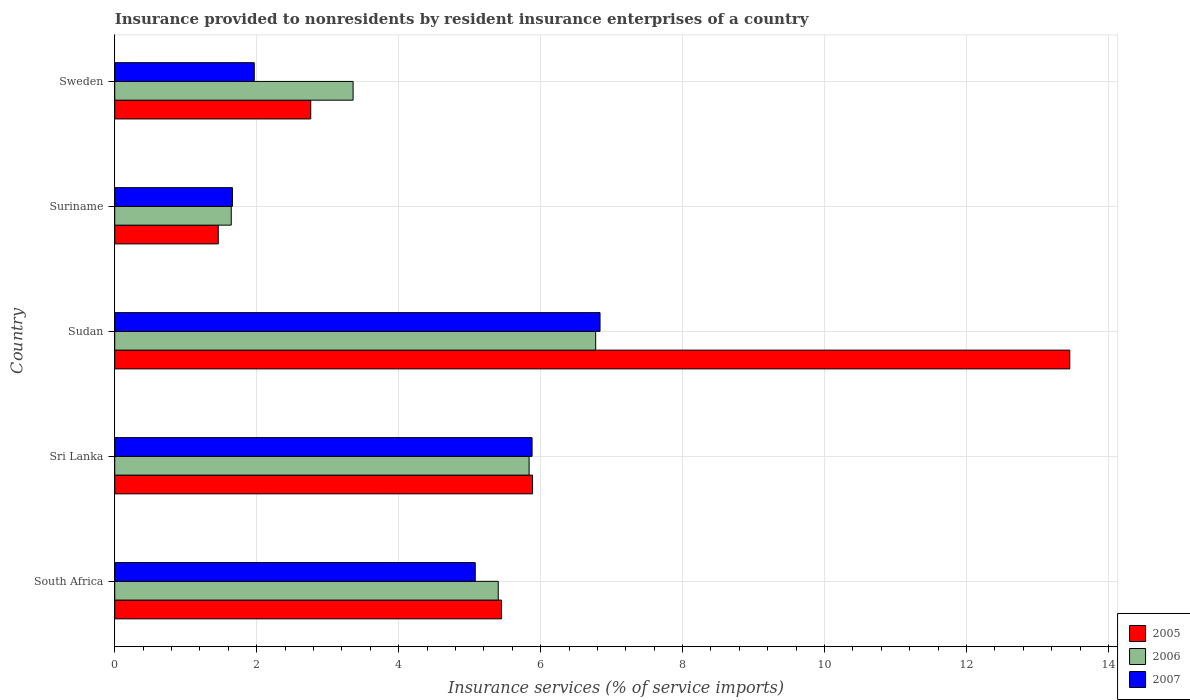How many different coloured bars are there?
Provide a short and direct response. 3. Are the number of bars on each tick of the Y-axis equal?
Offer a terse response. Yes. How many bars are there on the 3rd tick from the top?
Make the answer very short. 3. What is the label of the 5th group of bars from the top?
Provide a succinct answer. South Africa. In how many cases, is the number of bars for a given country not equal to the number of legend labels?
Provide a succinct answer. 0. What is the insurance provided to nonresidents in 2007 in Suriname?
Offer a terse response. 1.66. Across all countries, what is the maximum insurance provided to nonresidents in 2006?
Ensure brevity in your answer.  6.78. Across all countries, what is the minimum insurance provided to nonresidents in 2005?
Offer a very short reply. 1.46. In which country was the insurance provided to nonresidents in 2006 maximum?
Your response must be concise. Sudan. In which country was the insurance provided to nonresidents in 2007 minimum?
Give a very brief answer. Suriname. What is the total insurance provided to nonresidents in 2005 in the graph?
Provide a succinct answer. 29.01. What is the difference between the insurance provided to nonresidents in 2005 in South Africa and that in Suriname?
Provide a short and direct response. 3.99. What is the difference between the insurance provided to nonresidents in 2007 in Sudan and the insurance provided to nonresidents in 2006 in Sweden?
Keep it short and to the point. 3.48. What is the average insurance provided to nonresidents in 2005 per country?
Your answer should be compact. 5.8. What is the difference between the insurance provided to nonresidents in 2006 and insurance provided to nonresidents in 2005 in Sudan?
Give a very brief answer. -6.68. What is the ratio of the insurance provided to nonresidents in 2005 in South Africa to that in Sri Lanka?
Ensure brevity in your answer.  0.93. What is the difference between the highest and the second highest insurance provided to nonresidents in 2006?
Provide a succinct answer. 0.94. What is the difference between the highest and the lowest insurance provided to nonresidents in 2005?
Your answer should be very brief. 12. What does the 2nd bar from the top in Sri Lanka represents?
Ensure brevity in your answer.  2006. What does the 3rd bar from the bottom in South Africa represents?
Ensure brevity in your answer.  2007. Is it the case that in every country, the sum of the insurance provided to nonresidents in 2005 and insurance provided to nonresidents in 2006 is greater than the insurance provided to nonresidents in 2007?
Provide a succinct answer. Yes. How many bars are there?
Give a very brief answer. 15. Are all the bars in the graph horizontal?
Keep it short and to the point. Yes. How many countries are there in the graph?
Offer a terse response. 5. What is the difference between two consecutive major ticks on the X-axis?
Your answer should be compact. 2. Where does the legend appear in the graph?
Make the answer very short. Bottom right. How many legend labels are there?
Your answer should be very brief. 3. How are the legend labels stacked?
Offer a terse response. Vertical. What is the title of the graph?
Keep it short and to the point. Insurance provided to nonresidents by resident insurance enterprises of a country. Does "1970" appear as one of the legend labels in the graph?
Keep it short and to the point. No. What is the label or title of the X-axis?
Ensure brevity in your answer.  Insurance services (% of service imports). What is the Insurance services (% of service imports) of 2005 in South Africa?
Your response must be concise. 5.45. What is the Insurance services (% of service imports) in 2006 in South Africa?
Your response must be concise. 5.4. What is the Insurance services (% of service imports) of 2007 in South Africa?
Your answer should be compact. 5.08. What is the Insurance services (% of service imports) of 2005 in Sri Lanka?
Give a very brief answer. 5.89. What is the Insurance services (% of service imports) in 2006 in Sri Lanka?
Offer a very short reply. 5.84. What is the Insurance services (% of service imports) of 2007 in Sri Lanka?
Your answer should be very brief. 5.88. What is the Insurance services (% of service imports) of 2005 in Sudan?
Your response must be concise. 13.46. What is the Insurance services (% of service imports) in 2006 in Sudan?
Your answer should be very brief. 6.78. What is the Insurance services (% of service imports) of 2007 in Sudan?
Keep it short and to the point. 6.84. What is the Insurance services (% of service imports) of 2005 in Suriname?
Offer a terse response. 1.46. What is the Insurance services (% of service imports) in 2006 in Suriname?
Offer a very short reply. 1.64. What is the Insurance services (% of service imports) of 2007 in Suriname?
Keep it short and to the point. 1.66. What is the Insurance services (% of service imports) of 2005 in Sweden?
Make the answer very short. 2.76. What is the Insurance services (% of service imports) in 2006 in Sweden?
Make the answer very short. 3.36. What is the Insurance services (% of service imports) in 2007 in Sweden?
Provide a short and direct response. 1.97. Across all countries, what is the maximum Insurance services (% of service imports) in 2005?
Your answer should be very brief. 13.46. Across all countries, what is the maximum Insurance services (% of service imports) of 2006?
Keep it short and to the point. 6.78. Across all countries, what is the maximum Insurance services (% of service imports) in 2007?
Provide a succinct answer. 6.84. Across all countries, what is the minimum Insurance services (% of service imports) in 2005?
Your response must be concise. 1.46. Across all countries, what is the minimum Insurance services (% of service imports) of 2006?
Give a very brief answer. 1.64. Across all countries, what is the minimum Insurance services (% of service imports) of 2007?
Your response must be concise. 1.66. What is the total Insurance services (% of service imports) in 2005 in the graph?
Make the answer very short. 29.01. What is the total Insurance services (% of service imports) of 2006 in the graph?
Provide a short and direct response. 23.01. What is the total Insurance services (% of service imports) of 2007 in the graph?
Ensure brevity in your answer.  21.42. What is the difference between the Insurance services (% of service imports) of 2005 in South Africa and that in Sri Lanka?
Provide a short and direct response. -0.44. What is the difference between the Insurance services (% of service imports) in 2006 in South Africa and that in Sri Lanka?
Provide a succinct answer. -0.43. What is the difference between the Insurance services (% of service imports) of 2007 in South Africa and that in Sri Lanka?
Your response must be concise. -0.8. What is the difference between the Insurance services (% of service imports) of 2005 in South Africa and that in Sudan?
Keep it short and to the point. -8.01. What is the difference between the Insurance services (% of service imports) in 2006 in South Africa and that in Sudan?
Offer a terse response. -1.37. What is the difference between the Insurance services (% of service imports) of 2007 in South Africa and that in Sudan?
Ensure brevity in your answer.  -1.76. What is the difference between the Insurance services (% of service imports) of 2005 in South Africa and that in Suriname?
Give a very brief answer. 3.99. What is the difference between the Insurance services (% of service imports) of 2006 in South Africa and that in Suriname?
Your answer should be very brief. 3.76. What is the difference between the Insurance services (% of service imports) in 2007 in South Africa and that in Suriname?
Your answer should be very brief. 3.42. What is the difference between the Insurance services (% of service imports) in 2005 in South Africa and that in Sweden?
Provide a succinct answer. 2.69. What is the difference between the Insurance services (% of service imports) of 2006 in South Africa and that in Sweden?
Offer a terse response. 2.04. What is the difference between the Insurance services (% of service imports) in 2007 in South Africa and that in Sweden?
Your answer should be very brief. 3.11. What is the difference between the Insurance services (% of service imports) in 2005 in Sri Lanka and that in Sudan?
Ensure brevity in your answer.  -7.57. What is the difference between the Insurance services (% of service imports) in 2006 in Sri Lanka and that in Sudan?
Give a very brief answer. -0.94. What is the difference between the Insurance services (% of service imports) of 2007 in Sri Lanka and that in Sudan?
Ensure brevity in your answer.  -0.96. What is the difference between the Insurance services (% of service imports) of 2005 in Sri Lanka and that in Suriname?
Provide a succinct answer. 4.43. What is the difference between the Insurance services (% of service imports) of 2006 in Sri Lanka and that in Suriname?
Your answer should be very brief. 4.2. What is the difference between the Insurance services (% of service imports) in 2007 in Sri Lanka and that in Suriname?
Provide a succinct answer. 4.22. What is the difference between the Insurance services (% of service imports) of 2005 in Sri Lanka and that in Sweden?
Keep it short and to the point. 3.13. What is the difference between the Insurance services (% of service imports) of 2006 in Sri Lanka and that in Sweden?
Make the answer very short. 2.48. What is the difference between the Insurance services (% of service imports) in 2007 in Sri Lanka and that in Sweden?
Keep it short and to the point. 3.91. What is the difference between the Insurance services (% of service imports) in 2005 in Sudan and that in Suriname?
Provide a short and direct response. 12. What is the difference between the Insurance services (% of service imports) of 2006 in Sudan and that in Suriname?
Give a very brief answer. 5.13. What is the difference between the Insurance services (% of service imports) in 2007 in Sudan and that in Suriname?
Make the answer very short. 5.18. What is the difference between the Insurance services (% of service imports) in 2005 in Sudan and that in Sweden?
Provide a succinct answer. 10.69. What is the difference between the Insurance services (% of service imports) of 2006 in Sudan and that in Sweden?
Keep it short and to the point. 3.42. What is the difference between the Insurance services (% of service imports) of 2007 in Sudan and that in Sweden?
Your response must be concise. 4.87. What is the difference between the Insurance services (% of service imports) in 2005 in Suriname and that in Sweden?
Provide a succinct answer. -1.3. What is the difference between the Insurance services (% of service imports) in 2006 in Suriname and that in Sweden?
Provide a short and direct response. -1.72. What is the difference between the Insurance services (% of service imports) of 2007 in Suriname and that in Sweden?
Offer a very short reply. -0.31. What is the difference between the Insurance services (% of service imports) of 2005 in South Africa and the Insurance services (% of service imports) of 2006 in Sri Lanka?
Provide a succinct answer. -0.39. What is the difference between the Insurance services (% of service imports) of 2005 in South Africa and the Insurance services (% of service imports) of 2007 in Sri Lanka?
Your answer should be very brief. -0.43. What is the difference between the Insurance services (% of service imports) in 2006 in South Africa and the Insurance services (% of service imports) in 2007 in Sri Lanka?
Your answer should be compact. -0.48. What is the difference between the Insurance services (% of service imports) in 2005 in South Africa and the Insurance services (% of service imports) in 2006 in Sudan?
Your response must be concise. -1.33. What is the difference between the Insurance services (% of service imports) of 2005 in South Africa and the Insurance services (% of service imports) of 2007 in Sudan?
Your answer should be very brief. -1.39. What is the difference between the Insurance services (% of service imports) in 2006 in South Africa and the Insurance services (% of service imports) in 2007 in Sudan?
Give a very brief answer. -1.43. What is the difference between the Insurance services (% of service imports) of 2005 in South Africa and the Insurance services (% of service imports) of 2006 in Suriname?
Keep it short and to the point. 3.81. What is the difference between the Insurance services (% of service imports) in 2005 in South Africa and the Insurance services (% of service imports) in 2007 in Suriname?
Offer a terse response. 3.79. What is the difference between the Insurance services (% of service imports) of 2006 in South Africa and the Insurance services (% of service imports) of 2007 in Suriname?
Provide a succinct answer. 3.75. What is the difference between the Insurance services (% of service imports) of 2005 in South Africa and the Insurance services (% of service imports) of 2006 in Sweden?
Offer a terse response. 2.09. What is the difference between the Insurance services (% of service imports) in 2005 in South Africa and the Insurance services (% of service imports) in 2007 in Sweden?
Give a very brief answer. 3.48. What is the difference between the Insurance services (% of service imports) in 2006 in South Africa and the Insurance services (% of service imports) in 2007 in Sweden?
Your answer should be very brief. 3.44. What is the difference between the Insurance services (% of service imports) in 2005 in Sri Lanka and the Insurance services (% of service imports) in 2006 in Sudan?
Your response must be concise. -0.89. What is the difference between the Insurance services (% of service imports) of 2005 in Sri Lanka and the Insurance services (% of service imports) of 2007 in Sudan?
Your answer should be compact. -0.95. What is the difference between the Insurance services (% of service imports) in 2006 in Sri Lanka and the Insurance services (% of service imports) in 2007 in Sudan?
Ensure brevity in your answer.  -1. What is the difference between the Insurance services (% of service imports) in 2005 in Sri Lanka and the Insurance services (% of service imports) in 2006 in Suriname?
Offer a terse response. 4.24. What is the difference between the Insurance services (% of service imports) in 2005 in Sri Lanka and the Insurance services (% of service imports) in 2007 in Suriname?
Provide a succinct answer. 4.23. What is the difference between the Insurance services (% of service imports) in 2006 in Sri Lanka and the Insurance services (% of service imports) in 2007 in Suriname?
Provide a short and direct response. 4.18. What is the difference between the Insurance services (% of service imports) of 2005 in Sri Lanka and the Insurance services (% of service imports) of 2006 in Sweden?
Provide a succinct answer. 2.53. What is the difference between the Insurance services (% of service imports) of 2005 in Sri Lanka and the Insurance services (% of service imports) of 2007 in Sweden?
Make the answer very short. 3.92. What is the difference between the Insurance services (% of service imports) in 2006 in Sri Lanka and the Insurance services (% of service imports) in 2007 in Sweden?
Your answer should be compact. 3.87. What is the difference between the Insurance services (% of service imports) in 2005 in Sudan and the Insurance services (% of service imports) in 2006 in Suriname?
Offer a terse response. 11.81. What is the difference between the Insurance services (% of service imports) in 2005 in Sudan and the Insurance services (% of service imports) in 2007 in Suriname?
Provide a short and direct response. 11.8. What is the difference between the Insurance services (% of service imports) in 2006 in Sudan and the Insurance services (% of service imports) in 2007 in Suriname?
Make the answer very short. 5.12. What is the difference between the Insurance services (% of service imports) of 2005 in Sudan and the Insurance services (% of service imports) of 2006 in Sweden?
Ensure brevity in your answer.  10.1. What is the difference between the Insurance services (% of service imports) in 2005 in Sudan and the Insurance services (% of service imports) in 2007 in Sweden?
Your answer should be compact. 11.49. What is the difference between the Insurance services (% of service imports) of 2006 in Sudan and the Insurance services (% of service imports) of 2007 in Sweden?
Ensure brevity in your answer.  4.81. What is the difference between the Insurance services (% of service imports) of 2005 in Suriname and the Insurance services (% of service imports) of 2006 in Sweden?
Keep it short and to the point. -1.9. What is the difference between the Insurance services (% of service imports) in 2005 in Suriname and the Insurance services (% of service imports) in 2007 in Sweden?
Offer a very short reply. -0.51. What is the difference between the Insurance services (% of service imports) in 2006 in Suriname and the Insurance services (% of service imports) in 2007 in Sweden?
Your response must be concise. -0.32. What is the average Insurance services (% of service imports) in 2005 per country?
Your answer should be compact. 5.8. What is the average Insurance services (% of service imports) in 2006 per country?
Provide a short and direct response. 4.6. What is the average Insurance services (% of service imports) in 2007 per country?
Ensure brevity in your answer.  4.28. What is the difference between the Insurance services (% of service imports) of 2005 and Insurance services (% of service imports) of 2006 in South Africa?
Provide a succinct answer. 0.05. What is the difference between the Insurance services (% of service imports) in 2005 and Insurance services (% of service imports) in 2007 in South Africa?
Ensure brevity in your answer.  0.37. What is the difference between the Insurance services (% of service imports) of 2006 and Insurance services (% of service imports) of 2007 in South Africa?
Provide a short and direct response. 0.32. What is the difference between the Insurance services (% of service imports) of 2005 and Insurance services (% of service imports) of 2006 in Sri Lanka?
Keep it short and to the point. 0.05. What is the difference between the Insurance services (% of service imports) in 2005 and Insurance services (% of service imports) in 2007 in Sri Lanka?
Provide a short and direct response. 0.01. What is the difference between the Insurance services (% of service imports) in 2006 and Insurance services (% of service imports) in 2007 in Sri Lanka?
Your response must be concise. -0.04. What is the difference between the Insurance services (% of service imports) of 2005 and Insurance services (% of service imports) of 2006 in Sudan?
Give a very brief answer. 6.68. What is the difference between the Insurance services (% of service imports) of 2005 and Insurance services (% of service imports) of 2007 in Sudan?
Make the answer very short. 6.62. What is the difference between the Insurance services (% of service imports) in 2006 and Insurance services (% of service imports) in 2007 in Sudan?
Ensure brevity in your answer.  -0.06. What is the difference between the Insurance services (% of service imports) in 2005 and Insurance services (% of service imports) in 2006 in Suriname?
Provide a short and direct response. -0.18. What is the difference between the Insurance services (% of service imports) of 2005 and Insurance services (% of service imports) of 2007 in Suriname?
Your answer should be compact. -0.2. What is the difference between the Insurance services (% of service imports) in 2006 and Insurance services (% of service imports) in 2007 in Suriname?
Your answer should be very brief. -0.02. What is the difference between the Insurance services (% of service imports) of 2005 and Insurance services (% of service imports) of 2006 in Sweden?
Make the answer very short. -0.6. What is the difference between the Insurance services (% of service imports) in 2005 and Insurance services (% of service imports) in 2007 in Sweden?
Make the answer very short. 0.8. What is the difference between the Insurance services (% of service imports) of 2006 and Insurance services (% of service imports) of 2007 in Sweden?
Your answer should be very brief. 1.39. What is the ratio of the Insurance services (% of service imports) in 2005 in South Africa to that in Sri Lanka?
Make the answer very short. 0.93. What is the ratio of the Insurance services (% of service imports) of 2006 in South Africa to that in Sri Lanka?
Offer a very short reply. 0.93. What is the ratio of the Insurance services (% of service imports) of 2007 in South Africa to that in Sri Lanka?
Provide a succinct answer. 0.86. What is the ratio of the Insurance services (% of service imports) in 2005 in South Africa to that in Sudan?
Make the answer very short. 0.41. What is the ratio of the Insurance services (% of service imports) in 2006 in South Africa to that in Sudan?
Your response must be concise. 0.8. What is the ratio of the Insurance services (% of service imports) in 2007 in South Africa to that in Sudan?
Offer a terse response. 0.74. What is the ratio of the Insurance services (% of service imports) of 2005 in South Africa to that in Suriname?
Make the answer very short. 3.74. What is the ratio of the Insurance services (% of service imports) in 2006 in South Africa to that in Suriname?
Your response must be concise. 3.29. What is the ratio of the Insurance services (% of service imports) of 2007 in South Africa to that in Suriname?
Offer a very short reply. 3.06. What is the ratio of the Insurance services (% of service imports) in 2005 in South Africa to that in Sweden?
Give a very brief answer. 1.97. What is the ratio of the Insurance services (% of service imports) in 2006 in South Africa to that in Sweden?
Make the answer very short. 1.61. What is the ratio of the Insurance services (% of service imports) in 2007 in South Africa to that in Sweden?
Your answer should be compact. 2.58. What is the ratio of the Insurance services (% of service imports) of 2005 in Sri Lanka to that in Sudan?
Ensure brevity in your answer.  0.44. What is the ratio of the Insurance services (% of service imports) in 2006 in Sri Lanka to that in Sudan?
Give a very brief answer. 0.86. What is the ratio of the Insurance services (% of service imports) of 2007 in Sri Lanka to that in Sudan?
Make the answer very short. 0.86. What is the ratio of the Insurance services (% of service imports) of 2005 in Sri Lanka to that in Suriname?
Offer a terse response. 4.04. What is the ratio of the Insurance services (% of service imports) in 2006 in Sri Lanka to that in Suriname?
Your answer should be very brief. 3.56. What is the ratio of the Insurance services (% of service imports) in 2007 in Sri Lanka to that in Suriname?
Provide a short and direct response. 3.55. What is the ratio of the Insurance services (% of service imports) of 2005 in Sri Lanka to that in Sweden?
Offer a terse response. 2.13. What is the ratio of the Insurance services (% of service imports) of 2006 in Sri Lanka to that in Sweden?
Give a very brief answer. 1.74. What is the ratio of the Insurance services (% of service imports) in 2007 in Sri Lanka to that in Sweden?
Keep it short and to the point. 2.99. What is the ratio of the Insurance services (% of service imports) of 2005 in Sudan to that in Suriname?
Provide a short and direct response. 9.23. What is the ratio of the Insurance services (% of service imports) of 2006 in Sudan to that in Suriname?
Offer a terse response. 4.13. What is the ratio of the Insurance services (% of service imports) of 2007 in Sudan to that in Suriname?
Make the answer very short. 4.12. What is the ratio of the Insurance services (% of service imports) in 2005 in Sudan to that in Sweden?
Your answer should be compact. 4.87. What is the ratio of the Insurance services (% of service imports) of 2006 in Sudan to that in Sweden?
Your response must be concise. 2.02. What is the ratio of the Insurance services (% of service imports) of 2007 in Sudan to that in Sweden?
Your answer should be very brief. 3.48. What is the ratio of the Insurance services (% of service imports) of 2005 in Suriname to that in Sweden?
Your response must be concise. 0.53. What is the ratio of the Insurance services (% of service imports) in 2006 in Suriname to that in Sweden?
Offer a very short reply. 0.49. What is the ratio of the Insurance services (% of service imports) in 2007 in Suriname to that in Sweden?
Your answer should be compact. 0.84. What is the difference between the highest and the second highest Insurance services (% of service imports) of 2005?
Offer a terse response. 7.57. What is the difference between the highest and the second highest Insurance services (% of service imports) of 2006?
Give a very brief answer. 0.94. What is the difference between the highest and the second highest Insurance services (% of service imports) in 2007?
Your answer should be compact. 0.96. What is the difference between the highest and the lowest Insurance services (% of service imports) in 2005?
Your answer should be very brief. 12. What is the difference between the highest and the lowest Insurance services (% of service imports) in 2006?
Give a very brief answer. 5.13. What is the difference between the highest and the lowest Insurance services (% of service imports) in 2007?
Give a very brief answer. 5.18. 